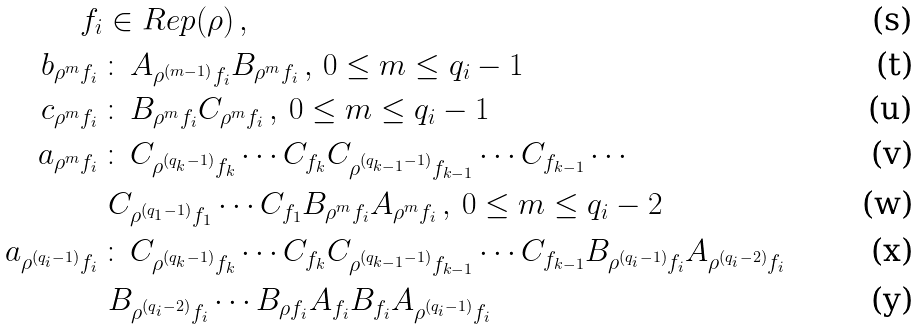<formula> <loc_0><loc_0><loc_500><loc_500>f _ { i } & \in R e p ( \rho ) \, , \\ b _ { \rho ^ { m } f _ { i } } \, & \colon \, A _ { \rho ^ { ( m - 1 ) } f _ { i } } B _ { \rho ^ { m } f _ { i } } \, , \, 0 \leq m \leq q _ { i } - 1 \\ c _ { \rho ^ { m } f _ { i } } \, & \colon \, B _ { \rho ^ { m } f _ { i } } C _ { \rho ^ { m } f _ { i } } \, , \, 0 \leq m \leq q _ { i } - 1 \\ a _ { \rho ^ { m } f _ { i } } \, & \colon \, C _ { \rho ^ { ( q _ { k } - 1 ) } f _ { k } } \cdots C _ { f _ { k } } C _ { \rho ^ { ( q _ { k - 1 } - 1 ) } f _ { k - 1 } } \cdots C _ { f _ { k - 1 } } \cdots \\ & \, C _ { \rho ^ { ( q _ { 1 } - 1 ) } f _ { 1 } } \cdots C _ { f _ { 1 } } B _ { \rho ^ { m } f _ { i } } A _ { \rho ^ { m } f _ { i } } \, , \, 0 \leq m \leq q _ { i } - 2 \\ a _ { \rho ^ { ( q _ { i } - 1 ) } f _ { i } } \, & \colon \, C _ { \rho ^ { ( q _ { k } - 1 ) } f _ { k } } \cdots C _ { f _ { k } } C _ { \rho ^ { ( q _ { k - 1 } - 1 ) } f _ { k - 1 } } \cdots C _ { f _ { k - 1 } } B _ { \rho ^ { ( q _ { i } - 1 ) } f _ { i } } A _ { \rho ^ { ( q _ { i } - 2 ) } f _ { i } } \\ & \, B _ { \rho ^ { ( q _ { i } - 2 ) } f _ { i } } \cdots B _ { \rho f _ { i } } A _ { f _ { i } } B _ { f _ { i } } A _ { \rho ^ { ( q _ { i } - 1 ) } f _ { i } }</formula> 